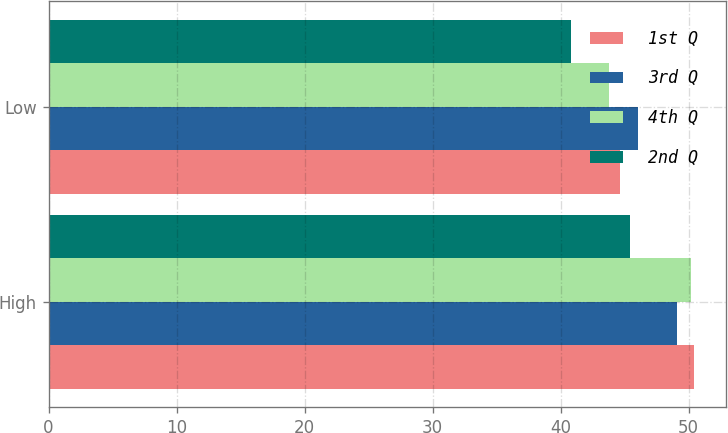Convert chart to OTSL. <chart><loc_0><loc_0><loc_500><loc_500><stacked_bar_chart><ecel><fcel>High<fcel>Low<nl><fcel>1st Q<fcel>50.42<fcel>44.62<nl><fcel>3rd Q<fcel>49.08<fcel>46.03<nl><fcel>4th Q<fcel>50.16<fcel>43.77<nl><fcel>2nd Q<fcel>45.42<fcel>40.83<nl></chart> 